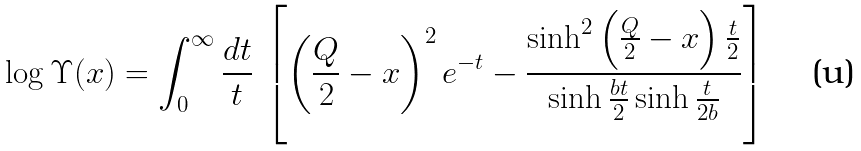<formula> <loc_0><loc_0><loc_500><loc_500>\log \Upsilon ( x ) = \int _ { 0 } ^ { \infty } \frac { d t } { t } \, \left [ \left ( \frac { Q } { 2 } - x \right ) ^ { 2 } e ^ { - t } - \frac { \sinh ^ { 2 } \left ( \frac { Q } { 2 } - x \right ) \frac { t } { 2 } } { \sinh \frac { b t } { 2 } \sinh \frac { t } { 2 b } } \right ]</formula> 